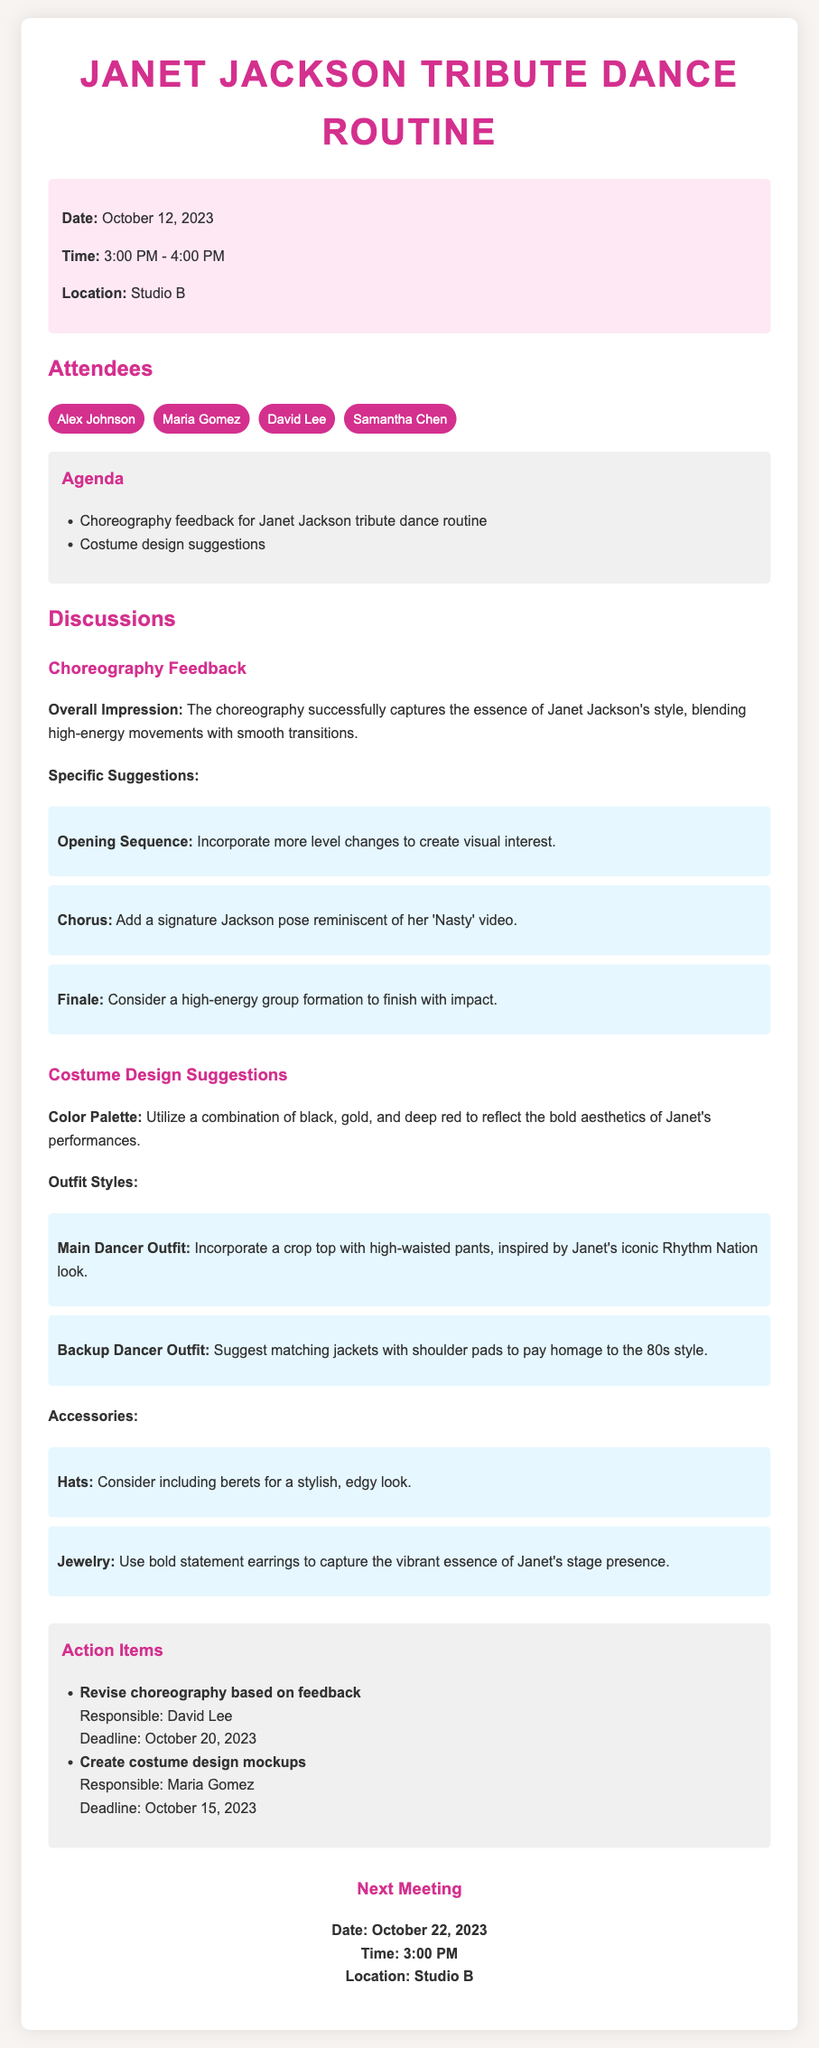What is the date of the meeting? The date of the meeting is mentioned clearly in the meeting info section.
Answer: October 12, 2023 Who is responsible for revising the choreography? The action items section specifies the individual responsible for this task.
Answer: David Lee What color palette is suggested for the costume design? The costume design suggestions section provides the recommended colors.
Answer: Black, gold, and deep red What is one specific suggestion for the opening sequence? The choreography feedback section lists specific suggestions for improvement.
Answer: Incorporate more level changes When is the next meeting scheduled? The next meeting section clearly states the date and time of the upcoming meeting.
Answer: October 22, 2023 What style is suggested for the main dancer outfit? The costume design suggestions outline the preferred style for the main dancer.
Answer: Crop top with high-waisted pants What type of accessory is proposed for the dancers? The costume design suggestions mention specific accessories for costume enhancement.
Answer: Berets What was the overall impression of the choreography? The discussions section provides an overall impression of the choreography presented.
Answer: Successfully captures the essence of Janet Jackson's style 